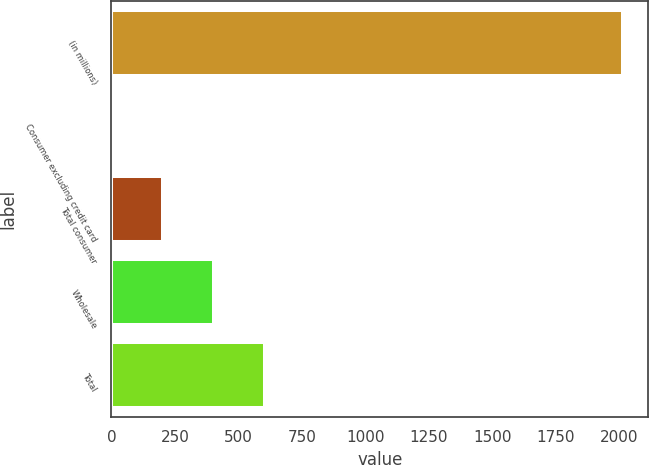Convert chart. <chart><loc_0><loc_0><loc_500><loc_500><bar_chart><fcel>(in millions)<fcel>Consumer excluding credit card<fcel>Total consumer<fcel>Wholesale<fcel>Total<nl><fcel>2015<fcel>1<fcel>202.4<fcel>403.8<fcel>605.2<nl></chart> 